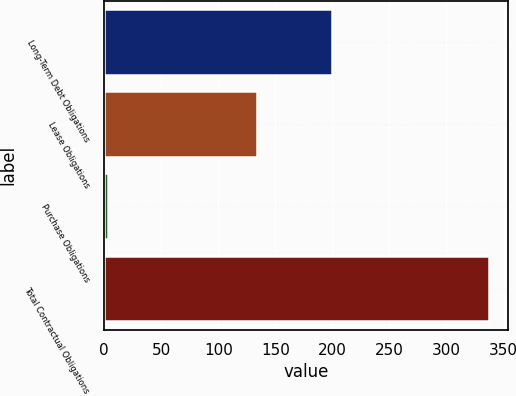Convert chart to OTSL. <chart><loc_0><loc_0><loc_500><loc_500><bar_chart><fcel>Long-Term Debt Obligations<fcel>Lease Obligations<fcel>Purchase Obligations<fcel>Total Contractual Obligations<nl><fcel>200<fcel>134<fcel>3<fcel>337<nl></chart> 